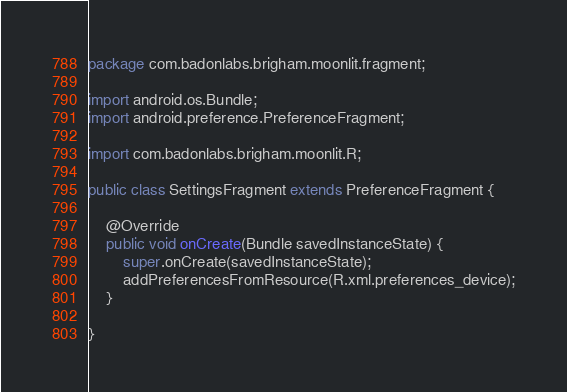Convert code to text. <code><loc_0><loc_0><loc_500><loc_500><_Java_>package com.badonlabs.brigham.moonlit.fragment;

import android.os.Bundle;
import android.preference.PreferenceFragment;

import com.badonlabs.brigham.moonlit.R;

public class SettingsFragment extends PreferenceFragment {

    @Override
    public void onCreate(Bundle savedInstanceState) {
        super.onCreate(savedInstanceState);
        addPreferencesFromResource(R.xml.preferences_device);
    }

}
</code> 